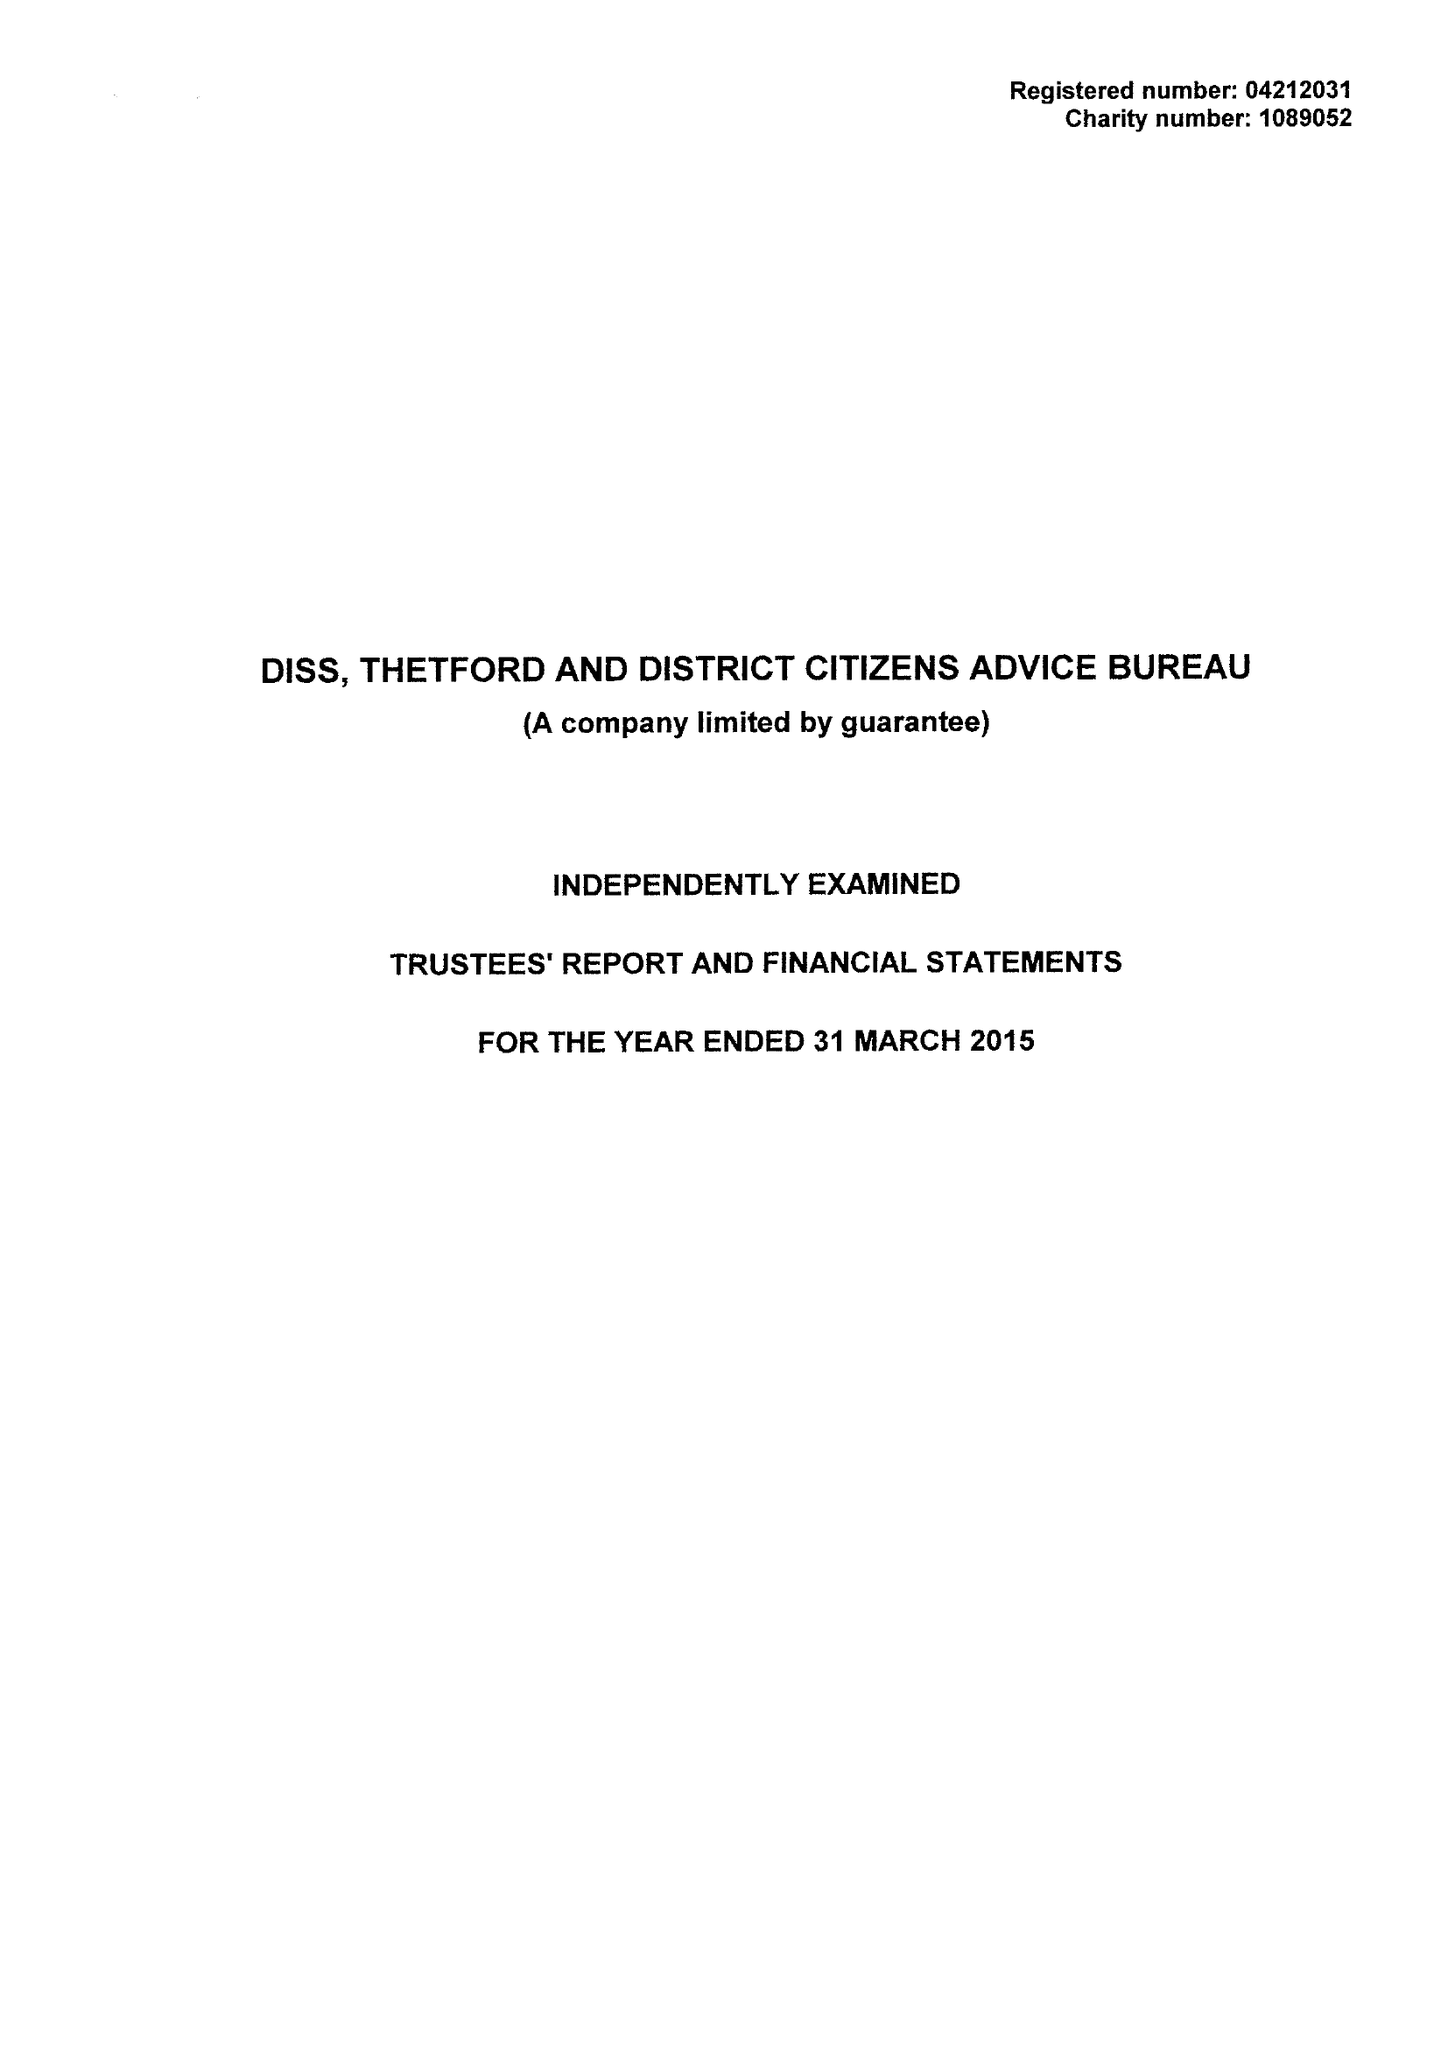What is the value for the address__post_town?
Answer the question using a single word or phrase. DISS 